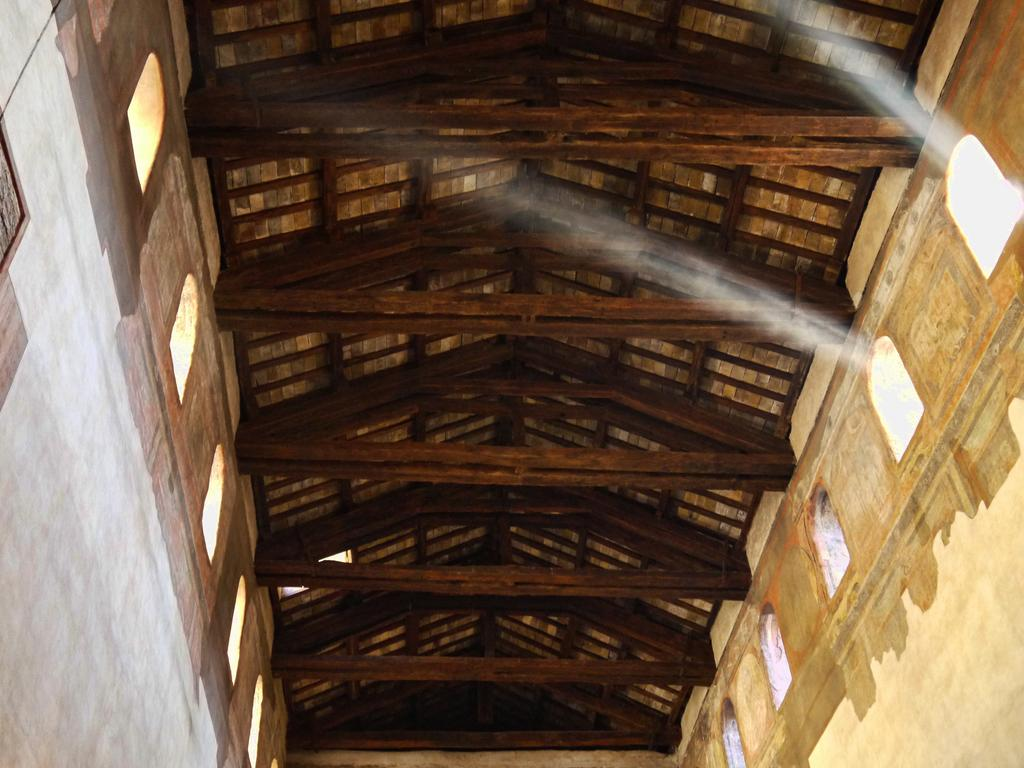What type of surface is visible in the image? The image shows the rooftop of a room. What material is the rooftop made of? The rooftop is made of wood. Are there any structural elements visible on the rooftop? Yes, the rooftop has beams. How many eggs are hidden among the beams on the rooftop? There are no eggs present on the rooftop in the image. 